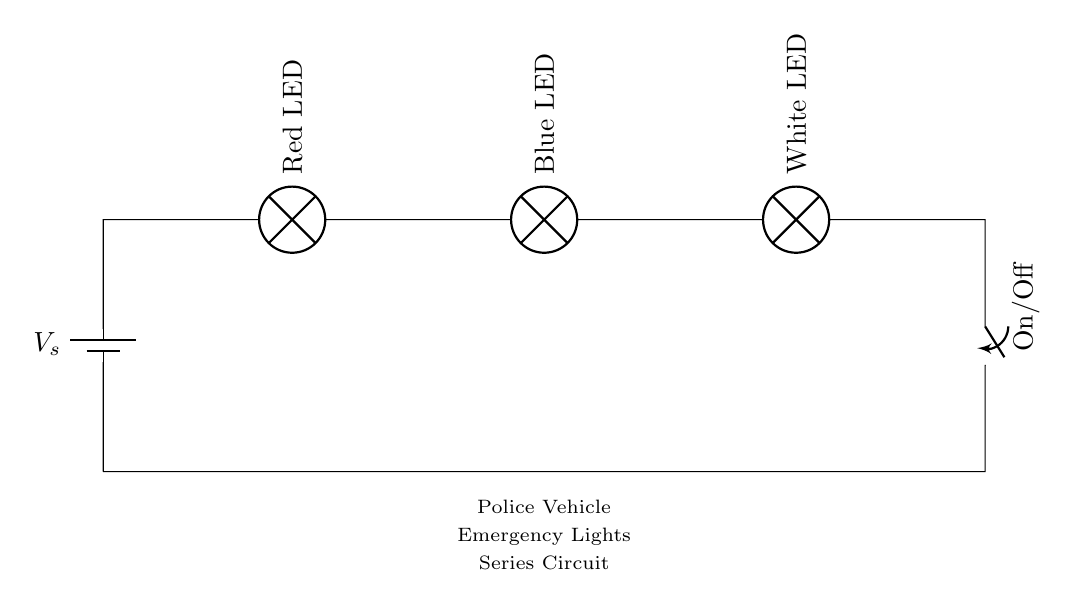What is the power source of this circuit? The power source is a battery commonly denoted as V_s in the circuit diagram, which provides the necessary voltage to drive the current through the lights.
Answer: battery How many LEDs are in the circuit? The circuit contains three LEDs: a Red LED, a Blue LED, and a White LED, each connected in series.
Answer: three What type of circuit is this? This is a series circuit, as all components are connected end-to-end, so current flows through each component sequentially.
Answer: series What happens if one LED fails in this circuit? If one LED fails, it creates an open circuit, which stops current flow to all components. Therefore, all LEDs will turn off, due to the nature of series circuits where current must flow through all parts.
Answer: all off What component is used to turn the emergency lights on or off? The circuit includes a switch labeled On/Off, which allows the user to control whether the current can flow through the circuit and thus turn the emergency lights on or off.
Answer: switch What is the effect of adding more LEDs in series to this circuit? Adding more LEDs in series will increase the total resistance, which can lower the current through the circuit if the voltage source does not change. This could cause the LEDs to dim or not light up if the source voltage is insufficient to forward bias all the added LEDs.
Answer: increases resistance What does the labeled value V_s represent? V_s represents the voltage supplied by the battery. It is critical as it determines how much potential difference is applied across the entire series circuit, affecting the brightness and functionality of the LEDs.
Answer: voltage source 